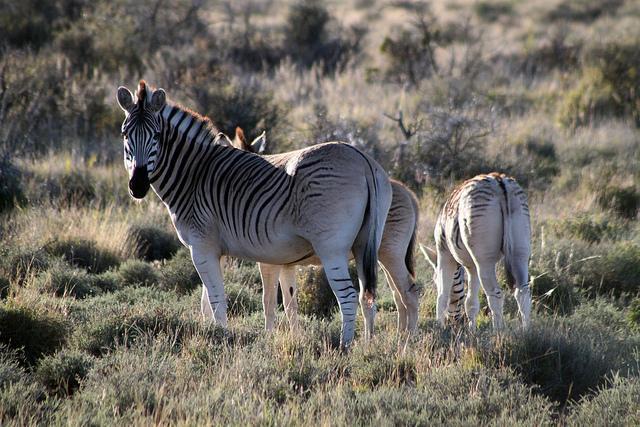How many zebras can be seen?
Give a very brief answer. 3. 